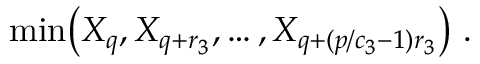Convert formula to latex. <formula><loc_0><loc_0><loc_500><loc_500>\min \left ( X _ { q } , X _ { q + r _ { 3 } } , \dots , X _ { q + ( p / c _ { 3 } - 1 ) r _ { 3 } } \right ) \ .</formula> 